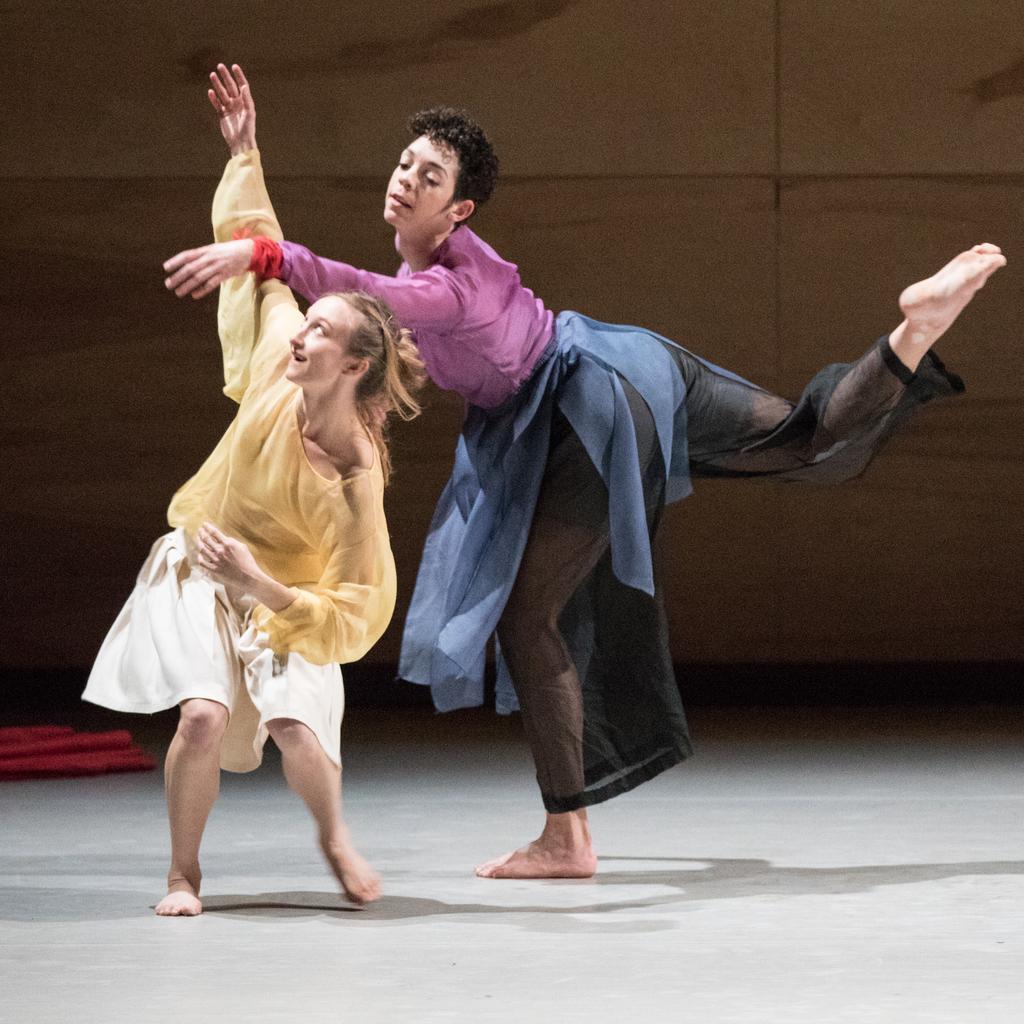Please provide a concise description of this image. In this picture, there are two women. One of the woman is wearing yellow top and white skirt. Another woman is wearing purple top and black trousers. In the background, there is a wall. 